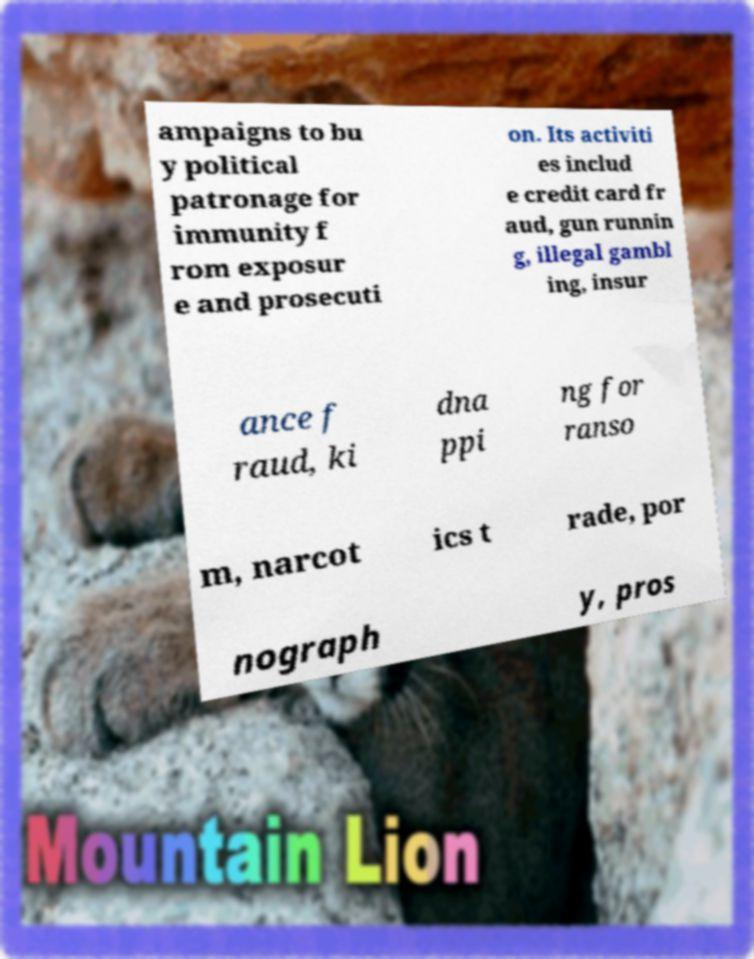Please identify and transcribe the text found in this image. ampaigns to bu y political patronage for immunity f rom exposur e and prosecuti on. Its activiti es includ e credit card fr aud, gun runnin g, illegal gambl ing, insur ance f raud, ki dna ppi ng for ranso m, narcot ics t rade, por nograph y, pros 